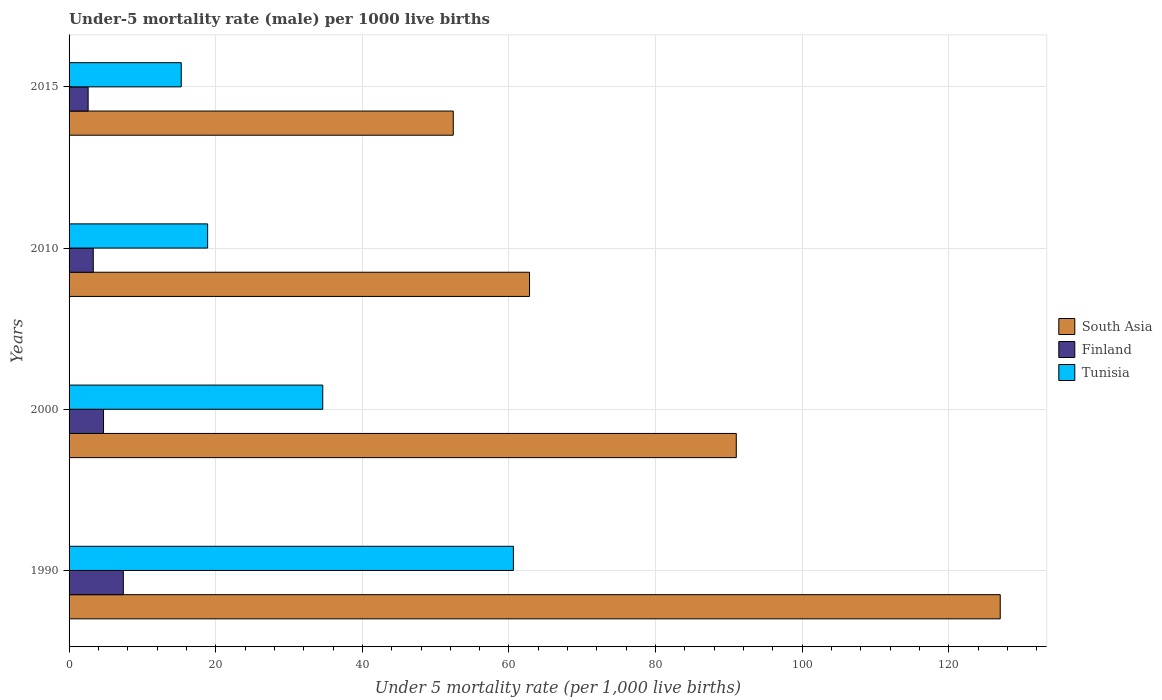Are the number of bars on each tick of the Y-axis equal?
Keep it short and to the point. Yes. How many bars are there on the 1st tick from the top?
Provide a short and direct response. 3. What is the label of the 1st group of bars from the top?
Offer a terse response. 2015. In how many cases, is the number of bars for a given year not equal to the number of legend labels?
Provide a short and direct response. 0. What is the under-five mortality rate in South Asia in 2000?
Offer a very short reply. 91. Across all years, what is the maximum under-five mortality rate in South Asia?
Your answer should be compact. 127. Across all years, what is the minimum under-five mortality rate in Finland?
Provide a succinct answer. 2.6. In which year was the under-five mortality rate in South Asia maximum?
Give a very brief answer. 1990. In which year was the under-five mortality rate in South Asia minimum?
Offer a terse response. 2015. What is the total under-five mortality rate in Finland in the graph?
Offer a terse response. 18. What is the difference between the under-five mortality rate in Tunisia in 2000 and that in 2015?
Give a very brief answer. 19.3. What is the difference between the under-five mortality rate in South Asia in 1990 and the under-five mortality rate in Tunisia in 2015?
Your response must be concise. 111.7. What is the average under-five mortality rate in Tunisia per year?
Provide a succinct answer. 32.35. In the year 1990, what is the difference between the under-five mortality rate in South Asia and under-five mortality rate in Finland?
Ensure brevity in your answer.  119.6. In how many years, is the under-five mortality rate in Tunisia greater than 36 ?
Keep it short and to the point. 1. What is the ratio of the under-five mortality rate in Tunisia in 1990 to that in 2010?
Your answer should be very brief. 3.21. What is the difference between the highest and the lowest under-five mortality rate in South Asia?
Ensure brevity in your answer.  74.6. What does the 2nd bar from the top in 2010 represents?
Your response must be concise. Finland. What does the 3rd bar from the bottom in 1990 represents?
Offer a very short reply. Tunisia. Is it the case that in every year, the sum of the under-five mortality rate in Finland and under-five mortality rate in Tunisia is greater than the under-five mortality rate in South Asia?
Your response must be concise. No. How many bars are there?
Your answer should be compact. 12. How many years are there in the graph?
Your answer should be very brief. 4. Does the graph contain grids?
Give a very brief answer. Yes. Where does the legend appear in the graph?
Provide a short and direct response. Center right. How many legend labels are there?
Provide a succinct answer. 3. What is the title of the graph?
Give a very brief answer. Under-5 mortality rate (male) per 1000 live births. Does "Brunei Darussalam" appear as one of the legend labels in the graph?
Provide a short and direct response. No. What is the label or title of the X-axis?
Provide a short and direct response. Under 5 mortality rate (per 1,0 live births). What is the Under 5 mortality rate (per 1,000 live births) of South Asia in 1990?
Provide a short and direct response. 127. What is the Under 5 mortality rate (per 1,000 live births) in Tunisia in 1990?
Offer a very short reply. 60.6. What is the Under 5 mortality rate (per 1,000 live births) in South Asia in 2000?
Your answer should be compact. 91. What is the Under 5 mortality rate (per 1,000 live births) of Finland in 2000?
Offer a very short reply. 4.7. What is the Under 5 mortality rate (per 1,000 live births) of Tunisia in 2000?
Provide a short and direct response. 34.6. What is the Under 5 mortality rate (per 1,000 live births) of South Asia in 2010?
Make the answer very short. 62.8. What is the Under 5 mortality rate (per 1,000 live births) of Tunisia in 2010?
Provide a short and direct response. 18.9. What is the Under 5 mortality rate (per 1,000 live births) of South Asia in 2015?
Offer a terse response. 52.4. What is the Under 5 mortality rate (per 1,000 live births) of Finland in 2015?
Your answer should be very brief. 2.6. Across all years, what is the maximum Under 5 mortality rate (per 1,000 live births) of South Asia?
Provide a short and direct response. 127. Across all years, what is the maximum Under 5 mortality rate (per 1,000 live births) of Tunisia?
Ensure brevity in your answer.  60.6. Across all years, what is the minimum Under 5 mortality rate (per 1,000 live births) in South Asia?
Ensure brevity in your answer.  52.4. Across all years, what is the minimum Under 5 mortality rate (per 1,000 live births) of Finland?
Your answer should be very brief. 2.6. Across all years, what is the minimum Under 5 mortality rate (per 1,000 live births) in Tunisia?
Ensure brevity in your answer.  15.3. What is the total Under 5 mortality rate (per 1,000 live births) of South Asia in the graph?
Provide a succinct answer. 333.2. What is the total Under 5 mortality rate (per 1,000 live births) of Tunisia in the graph?
Provide a succinct answer. 129.4. What is the difference between the Under 5 mortality rate (per 1,000 live births) in South Asia in 1990 and that in 2000?
Provide a succinct answer. 36. What is the difference between the Under 5 mortality rate (per 1,000 live births) of Finland in 1990 and that in 2000?
Make the answer very short. 2.7. What is the difference between the Under 5 mortality rate (per 1,000 live births) of Tunisia in 1990 and that in 2000?
Offer a very short reply. 26. What is the difference between the Under 5 mortality rate (per 1,000 live births) of South Asia in 1990 and that in 2010?
Make the answer very short. 64.2. What is the difference between the Under 5 mortality rate (per 1,000 live births) in Finland in 1990 and that in 2010?
Your answer should be very brief. 4.1. What is the difference between the Under 5 mortality rate (per 1,000 live births) in Tunisia in 1990 and that in 2010?
Offer a very short reply. 41.7. What is the difference between the Under 5 mortality rate (per 1,000 live births) of South Asia in 1990 and that in 2015?
Offer a very short reply. 74.6. What is the difference between the Under 5 mortality rate (per 1,000 live births) in Tunisia in 1990 and that in 2015?
Provide a succinct answer. 45.3. What is the difference between the Under 5 mortality rate (per 1,000 live births) in South Asia in 2000 and that in 2010?
Make the answer very short. 28.2. What is the difference between the Under 5 mortality rate (per 1,000 live births) of Finland in 2000 and that in 2010?
Provide a short and direct response. 1.4. What is the difference between the Under 5 mortality rate (per 1,000 live births) of South Asia in 2000 and that in 2015?
Make the answer very short. 38.6. What is the difference between the Under 5 mortality rate (per 1,000 live births) of Tunisia in 2000 and that in 2015?
Make the answer very short. 19.3. What is the difference between the Under 5 mortality rate (per 1,000 live births) of Finland in 2010 and that in 2015?
Give a very brief answer. 0.7. What is the difference between the Under 5 mortality rate (per 1,000 live births) in South Asia in 1990 and the Under 5 mortality rate (per 1,000 live births) in Finland in 2000?
Your answer should be compact. 122.3. What is the difference between the Under 5 mortality rate (per 1,000 live births) in South Asia in 1990 and the Under 5 mortality rate (per 1,000 live births) in Tunisia in 2000?
Provide a succinct answer. 92.4. What is the difference between the Under 5 mortality rate (per 1,000 live births) in Finland in 1990 and the Under 5 mortality rate (per 1,000 live births) in Tunisia in 2000?
Ensure brevity in your answer.  -27.2. What is the difference between the Under 5 mortality rate (per 1,000 live births) of South Asia in 1990 and the Under 5 mortality rate (per 1,000 live births) of Finland in 2010?
Give a very brief answer. 123.7. What is the difference between the Under 5 mortality rate (per 1,000 live births) in South Asia in 1990 and the Under 5 mortality rate (per 1,000 live births) in Tunisia in 2010?
Provide a short and direct response. 108.1. What is the difference between the Under 5 mortality rate (per 1,000 live births) in South Asia in 1990 and the Under 5 mortality rate (per 1,000 live births) in Finland in 2015?
Provide a succinct answer. 124.4. What is the difference between the Under 5 mortality rate (per 1,000 live births) in South Asia in 1990 and the Under 5 mortality rate (per 1,000 live births) in Tunisia in 2015?
Offer a very short reply. 111.7. What is the difference between the Under 5 mortality rate (per 1,000 live births) in Finland in 1990 and the Under 5 mortality rate (per 1,000 live births) in Tunisia in 2015?
Make the answer very short. -7.9. What is the difference between the Under 5 mortality rate (per 1,000 live births) in South Asia in 2000 and the Under 5 mortality rate (per 1,000 live births) in Finland in 2010?
Provide a succinct answer. 87.7. What is the difference between the Under 5 mortality rate (per 1,000 live births) in South Asia in 2000 and the Under 5 mortality rate (per 1,000 live births) in Tunisia in 2010?
Give a very brief answer. 72.1. What is the difference between the Under 5 mortality rate (per 1,000 live births) of Finland in 2000 and the Under 5 mortality rate (per 1,000 live births) of Tunisia in 2010?
Your response must be concise. -14.2. What is the difference between the Under 5 mortality rate (per 1,000 live births) of South Asia in 2000 and the Under 5 mortality rate (per 1,000 live births) of Finland in 2015?
Your response must be concise. 88.4. What is the difference between the Under 5 mortality rate (per 1,000 live births) in South Asia in 2000 and the Under 5 mortality rate (per 1,000 live births) in Tunisia in 2015?
Provide a succinct answer. 75.7. What is the difference between the Under 5 mortality rate (per 1,000 live births) of South Asia in 2010 and the Under 5 mortality rate (per 1,000 live births) of Finland in 2015?
Offer a terse response. 60.2. What is the difference between the Under 5 mortality rate (per 1,000 live births) in South Asia in 2010 and the Under 5 mortality rate (per 1,000 live births) in Tunisia in 2015?
Your answer should be very brief. 47.5. What is the difference between the Under 5 mortality rate (per 1,000 live births) in Finland in 2010 and the Under 5 mortality rate (per 1,000 live births) in Tunisia in 2015?
Provide a short and direct response. -12. What is the average Under 5 mortality rate (per 1,000 live births) in South Asia per year?
Keep it short and to the point. 83.3. What is the average Under 5 mortality rate (per 1,000 live births) in Finland per year?
Make the answer very short. 4.5. What is the average Under 5 mortality rate (per 1,000 live births) in Tunisia per year?
Your answer should be very brief. 32.35. In the year 1990, what is the difference between the Under 5 mortality rate (per 1,000 live births) of South Asia and Under 5 mortality rate (per 1,000 live births) of Finland?
Ensure brevity in your answer.  119.6. In the year 1990, what is the difference between the Under 5 mortality rate (per 1,000 live births) of South Asia and Under 5 mortality rate (per 1,000 live births) of Tunisia?
Give a very brief answer. 66.4. In the year 1990, what is the difference between the Under 5 mortality rate (per 1,000 live births) of Finland and Under 5 mortality rate (per 1,000 live births) of Tunisia?
Ensure brevity in your answer.  -53.2. In the year 2000, what is the difference between the Under 5 mortality rate (per 1,000 live births) of South Asia and Under 5 mortality rate (per 1,000 live births) of Finland?
Offer a very short reply. 86.3. In the year 2000, what is the difference between the Under 5 mortality rate (per 1,000 live births) of South Asia and Under 5 mortality rate (per 1,000 live births) of Tunisia?
Ensure brevity in your answer.  56.4. In the year 2000, what is the difference between the Under 5 mortality rate (per 1,000 live births) of Finland and Under 5 mortality rate (per 1,000 live births) of Tunisia?
Keep it short and to the point. -29.9. In the year 2010, what is the difference between the Under 5 mortality rate (per 1,000 live births) of South Asia and Under 5 mortality rate (per 1,000 live births) of Finland?
Ensure brevity in your answer.  59.5. In the year 2010, what is the difference between the Under 5 mortality rate (per 1,000 live births) of South Asia and Under 5 mortality rate (per 1,000 live births) of Tunisia?
Provide a short and direct response. 43.9. In the year 2010, what is the difference between the Under 5 mortality rate (per 1,000 live births) of Finland and Under 5 mortality rate (per 1,000 live births) of Tunisia?
Your response must be concise. -15.6. In the year 2015, what is the difference between the Under 5 mortality rate (per 1,000 live births) of South Asia and Under 5 mortality rate (per 1,000 live births) of Finland?
Ensure brevity in your answer.  49.8. In the year 2015, what is the difference between the Under 5 mortality rate (per 1,000 live births) of South Asia and Under 5 mortality rate (per 1,000 live births) of Tunisia?
Give a very brief answer. 37.1. In the year 2015, what is the difference between the Under 5 mortality rate (per 1,000 live births) of Finland and Under 5 mortality rate (per 1,000 live births) of Tunisia?
Your answer should be very brief. -12.7. What is the ratio of the Under 5 mortality rate (per 1,000 live births) in South Asia in 1990 to that in 2000?
Your answer should be compact. 1.4. What is the ratio of the Under 5 mortality rate (per 1,000 live births) of Finland in 1990 to that in 2000?
Offer a very short reply. 1.57. What is the ratio of the Under 5 mortality rate (per 1,000 live births) in Tunisia in 1990 to that in 2000?
Give a very brief answer. 1.75. What is the ratio of the Under 5 mortality rate (per 1,000 live births) of South Asia in 1990 to that in 2010?
Ensure brevity in your answer.  2.02. What is the ratio of the Under 5 mortality rate (per 1,000 live births) in Finland in 1990 to that in 2010?
Give a very brief answer. 2.24. What is the ratio of the Under 5 mortality rate (per 1,000 live births) of Tunisia in 1990 to that in 2010?
Offer a terse response. 3.21. What is the ratio of the Under 5 mortality rate (per 1,000 live births) of South Asia in 1990 to that in 2015?
Ensure brevity in your answer.  2.42. What is the ratio of the Under 5 mortality rate (per 1,000 live births) in Finland in 1990 to that in 2015?
Your response must be concise. 2.85. What is the ratio of the Under 5 mortality rate (per 1,000 live births) in Tunisia in 1990 to that in 2015?
Ensure brevity in your answer.  3.96. What is the ratio of the Under 5 mortality rate (per 1,000 live births) in South Asia in 2000 to that in 2010?
Make the answer very short. 1.45. What is the ratio of the Under 5 mortality rate (per 1,000 live births) in Finland in 2000 to that in 2010?
Provide a short and direct response. 1.42. What is the ratio of the Under 5 mortality rate (per 1,000 live births) of Tunisia in 2000 to that in 2010?
Your answer should be very brief. 1.83. What is the ratio of the Under 5 mortality rate (per 1,000 live births) of South Asia in 2000 to that in 2015?
Provide a succinct answer. 1.74. What is the ratio of the Under 5 mortality rate (per 1,000 live births) in Finland in 2000 to that in 2015?
Your response must be concise. 1.81. What is the ratio of the Under 5 mortality rate (per 1,000 live births) of Tunisia in 2000 to that in 2015?
Keep it short and to the point. 2.26. What is the ratio of the Under 5 mortality rate (per 1,000 live births) of South Asia in 2010 to that in 2015?
Offer a very short reply. 1.2. What is the ratio of the Under 5 mortality rate (per 1,000 live births) in Finland in 2010 to that in 2015?
Offer a terse response. 1.27. What is the ratio of the Under 5 mortality rate (per 1,000 live births) of Tunisia in 2010 to that in 2015?
Provide a short and direct response. 1.24. What is the difference between the highest and the lowest Under 5 mortality rate (per 1,000 live births) of South Asia?
Provide a succinct answer. 74.6. What is the difference between the highest and the lowest Under 5 mortality rate (per 1,000 live births) in Finland?
Provide a succinct answer. 4.8. What is the difference between the highest and the lowest Under 5 mortality rate (per 1,000 live births) in Tunisia?
Provide a short and direct response. 45.3. 